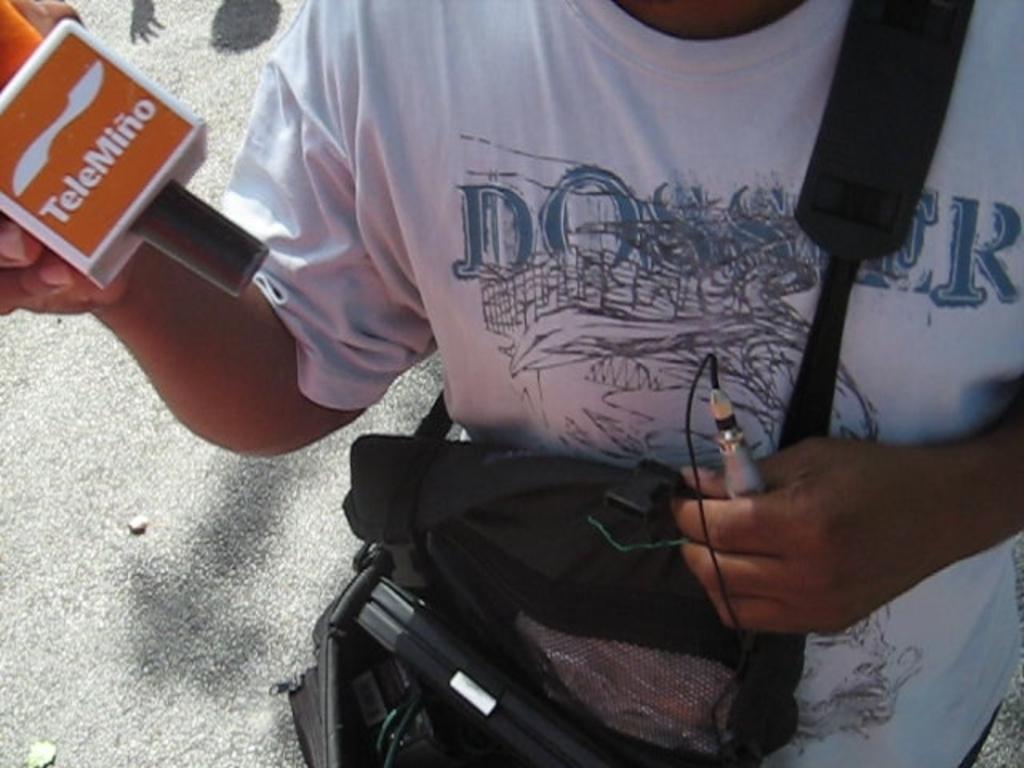How would you summarize this image in a sentence or two? In this image we can see a person holding a microphone in his hand and a device in other hand is carrying a bag containing some objects in it. 